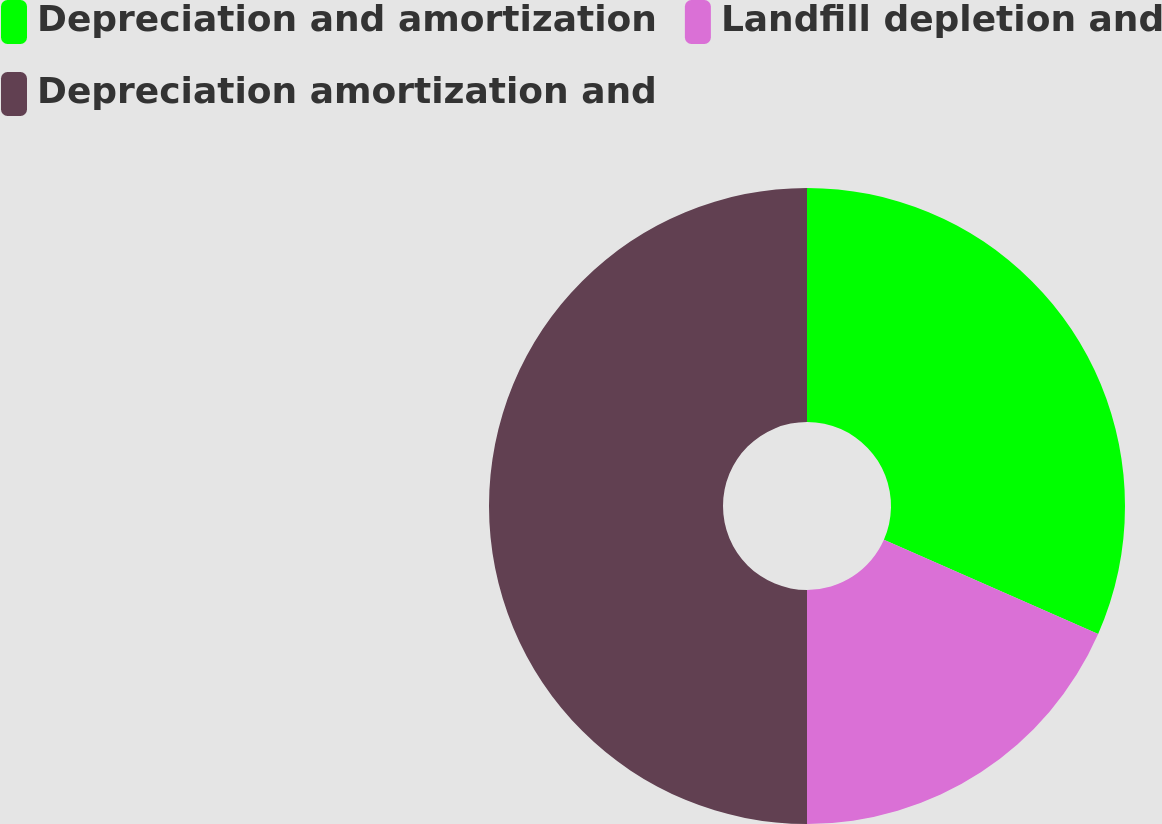Convert chart to OTSL. <chart><loc_0><loc_0><loc_500><loc_500><pie_chart><fcel>Depreciation and amortization<fcel>Landfill depletion and<fcel>Depreciation amortization and<nl><fcel>31.59%<fcel>18.41%<fcel>50.0%<nl></chart> 